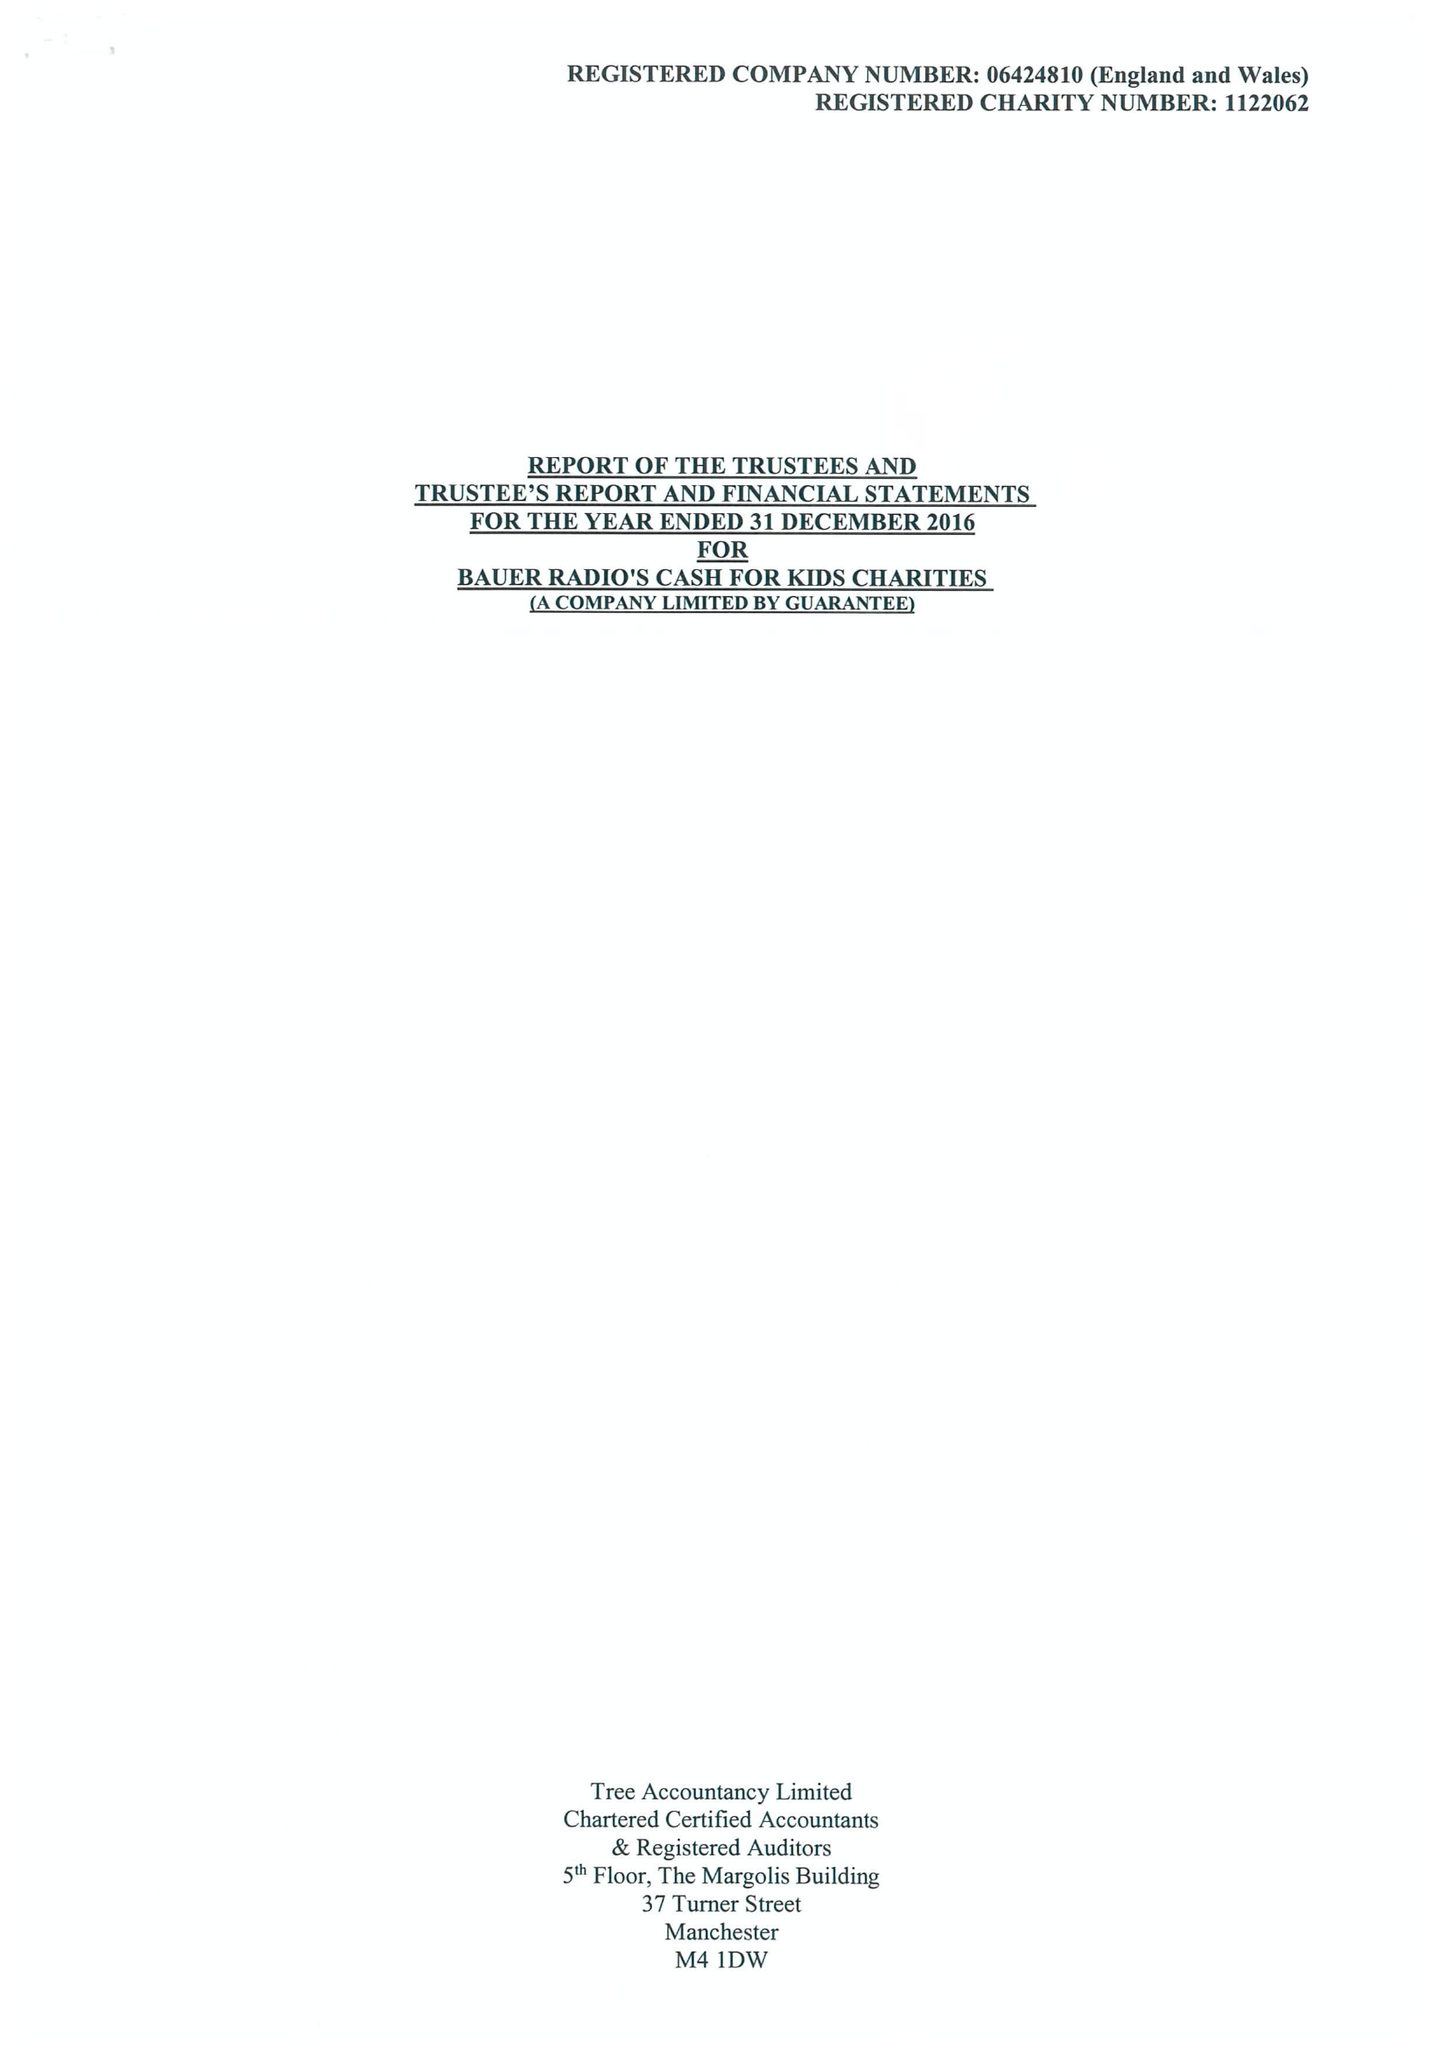What is the value for the address__post_town?
Answer the question using a single word or phrase. STOCKTON-ON-TEES 